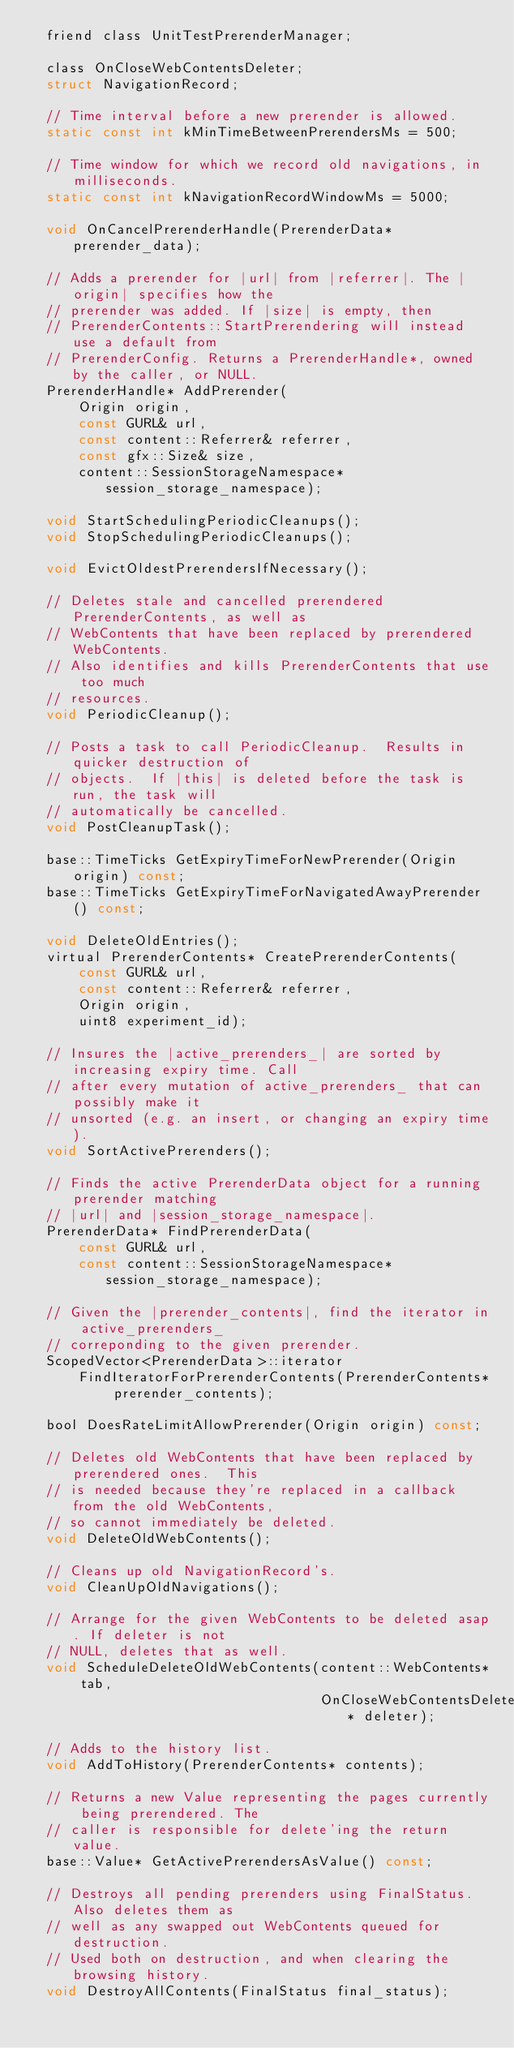<code> <loc_0><loc_0><loc_500><loc_500><_C_>  friend class UnitTestPrerenderManager;

  class OnCloseWebContentsDeleter;
  struct NavigationRecord;

  // Time interval before a new prerender is allowed.
  static const int kMinTimeBetweenPrerendersMs = 500;

  // Time window for which we record old navigations, in milliseconds.
  static const int kNavigationRecordWindowMs = 5000;

  void OnCancelPrerenderHandle(PrerenderData* prerender_data);

  // Adds a prerender for |url| from |referrer|. The |origin| specifies how the
  // prerender was added. If |size| is empty, then
  // PrerenderContents::StartPrerendering will instead use a default from
  // PrerenderConfig. Returns a PrerenderHandle*, owned by the caller, or NULL.
  PrerenderHandle* AddPrerender(
      Origin origin,
      const GURL& url,
      const content::Referrer& referrer,
      const gfx::Size& size,
      content::SessionStorageNamespace* session_storage_namespace);

  void StartSchedulingPeriodicCleanups();
  void StopSchedulingPeriodicCleanups();

  void EvictOldestPrerendersIfNecessary();

  // Deletes stale and cancelled prerendered PrerenderContents, as well as
  // WebContents that have been replaced by prerendered WebContents.
  // Also identifies and kills PrerenderContents that use too much
  // resources.
  void PeriodicCleanup();

  // Posts a task to call PeriodicCleanup.  Results in quicker destruction of
  // objects.  If |this| is deleted before the task is run, the task will
  // automatically be cancelled.
  void PostCleanupTask();

  base::TimeTicks GetExpiryTimeForNewPrerender(Origin origin) const;
  base::TimeTicks GetExpiryTimeForNavigatedAwayPrerender() const;

  void DeleteOldEntries();
  virtual PrerenderContents* CreatePrerenderContents(
      const GURL& url,
      const content::Referrer& referrer,
      Origin origin,
      uint8 experiment_id);

  // Insures the |active_prerenders_| are sorted by increasing expiry time. Call
  // after every mutation of active_prerenders_ that can possibly make it
  // unsorted (e.g. an insert, or changing an expiry time).
  void SortActivePrerenders();

  // Finds the active PrerenderData object for a running prerender matching
  // |url| and |session_storage_namespace|.
  PrerenderData* FindPrerenderData(
      const GURL& url,
      const content::SessionStorageNamespace* session_storage_namespace);

  // Given the |prerender_contents|, find the iterator in active_prerenders_
  // correponding to the given prerender.
  ScopedVector<PrerenderData>::iterator
      FindIteratorForPrerenderContents(PrerenderContents* prerender_contents);

  bool DoesRateLimitAllowPrerender(Origin origin) const;

  // Deletes old WebContents that have been replaced by prerendered ones.  This
  // is needed because they're replaced in a callback from the old WebContents,
  // so cannot immediately be deleted.
  void DeleteOldWebContents();

  // Cleans up old NavigationRecord's.
  void CleanUpOldNavigations();

  // Arrange for the given WebContents to be deleted asap. If deleter is not
  // NULL, deletes that as well.
  void ScheduleDeleteOldWebContents(content::WebContents* tab,
                                    OnCloseWebContentsDeleter* deleter);

  // Adds to the history list.
  void AddToHistory(PrerenderContents* contents);

  // Returns a new Value representing the pages currently being prerendered. The
  // caller is responsible for delete'ing the return value.
  base::Value* GetActivePrerendersAsValue() const;

  // Destroys all pending prerenders using FinalStatus.  Also deletes them as
  // well as any swapped out WebContents queued for destruction.
  // Used both on destruction, and when clearing the browsing history.
  void DestroyAllContents(FinalStatus final_status);
</code> 